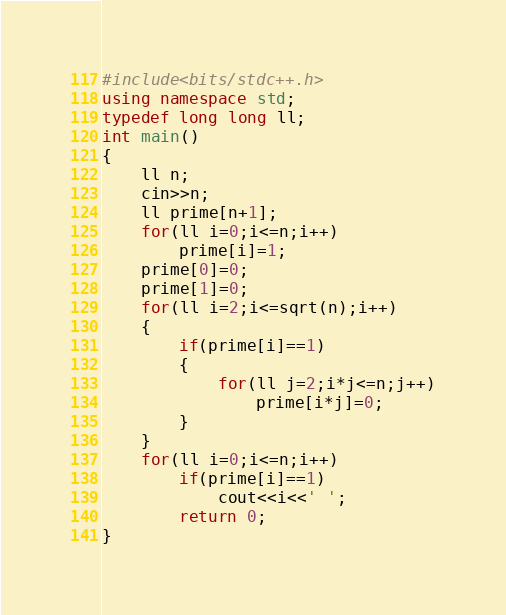Convert code to text. <code><loc_0><loc_0><loc_500><loc_500><_C++_>#include<bits/stdc++.h>
using namespace std;
typedef long long ll;
int main()
{
	ll n;
	cin>>n;
	ll prime[n+1];
	for(ll i=0;i<=n;i++)
		prime[i]=1;
	prime[0]=0;
	prime[1]=0;
	for(ll i=2;i<=sqrt(n);i++)
	{
		if(prime[i]==1)
		{
			for(ll j=2;i*j<=n;j++)
				prime[i*j]=0;
		}
	}
	for(ll i=0;i<=n;i++)
		if(prime[i]==1)
			cout<<i<<' ';
		return 0;
}</code> 